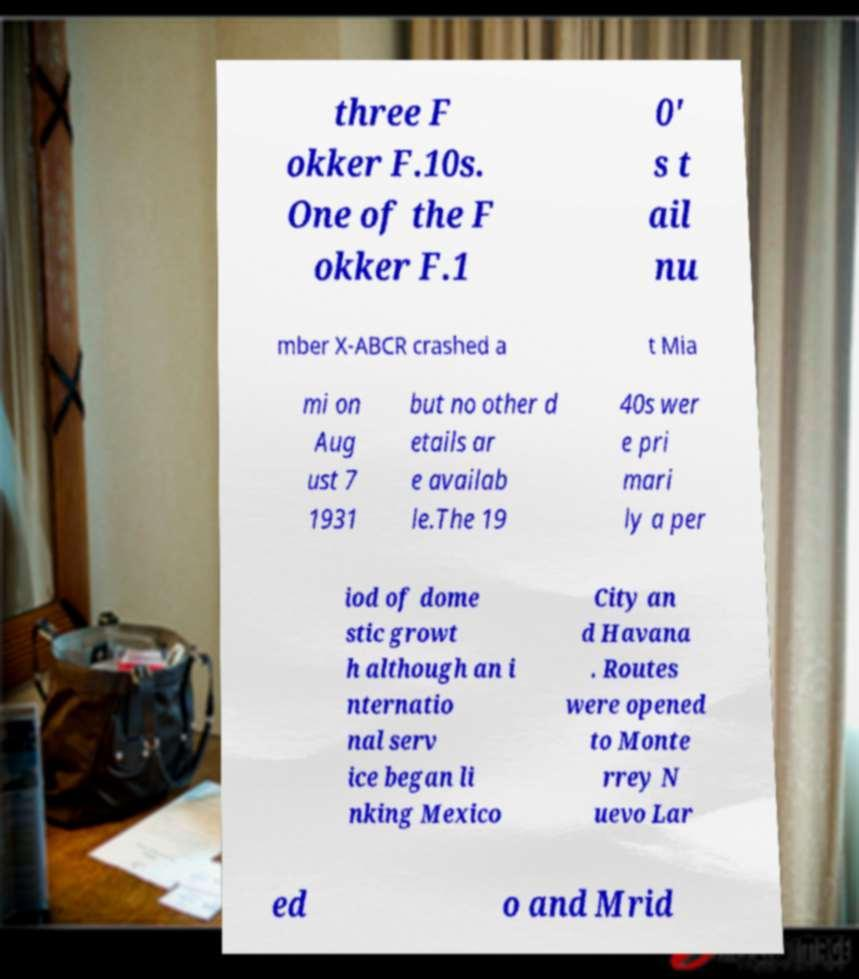Can you accurately transcribe the text from the provided image for me? three F okker F.10s. One of the F okker F.1 0' s t ail nu mber X-ABCR crashed a t Mia mi on Aug ust 7 1931 but no other d etails ar e availab le.The 19 40s wer e pri mari ly a per iod of dome stic growt h although an i nternatio nal serv ice began li nking Mexico City an d Havana . Routes were opened to Monte rrey N uevo Lar ed o and Mrid 